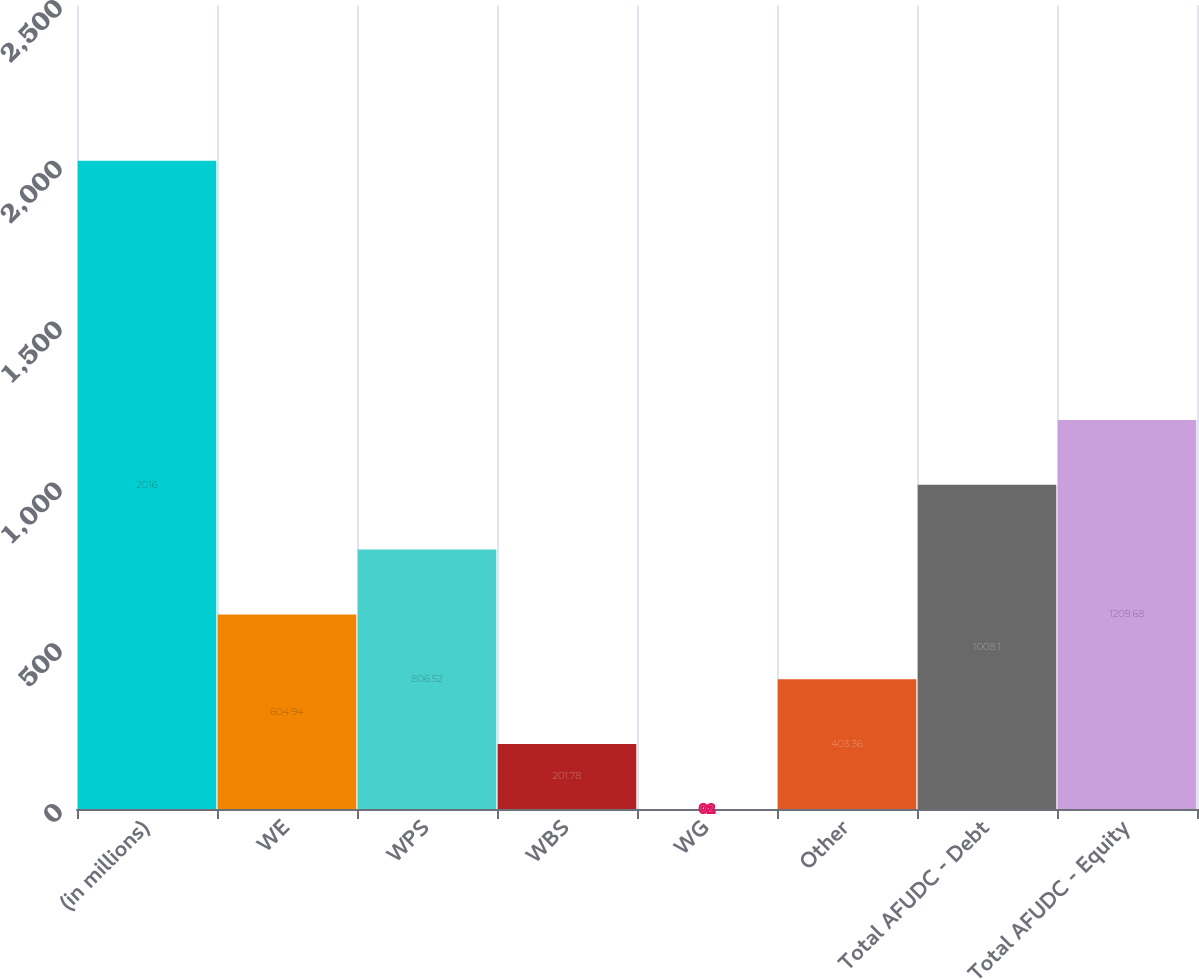<chart> <loc_0><loc_0><loc_500><loc_500><bar_chart><fcel>(in millions)<fcel>WE<fcel>WPS<fcel>WBS<fcel>WG<fcel>Other<fcel>Total AFUDC - Debt<fcel>Total AFUDC - Equity<nl><fcel>2016<fcel>604.94<fcel>806.52<fcel>201.78<fcel>0.2<fcel>403.36<fcel>1008.1<fcel>1209.68<nl></chart> 